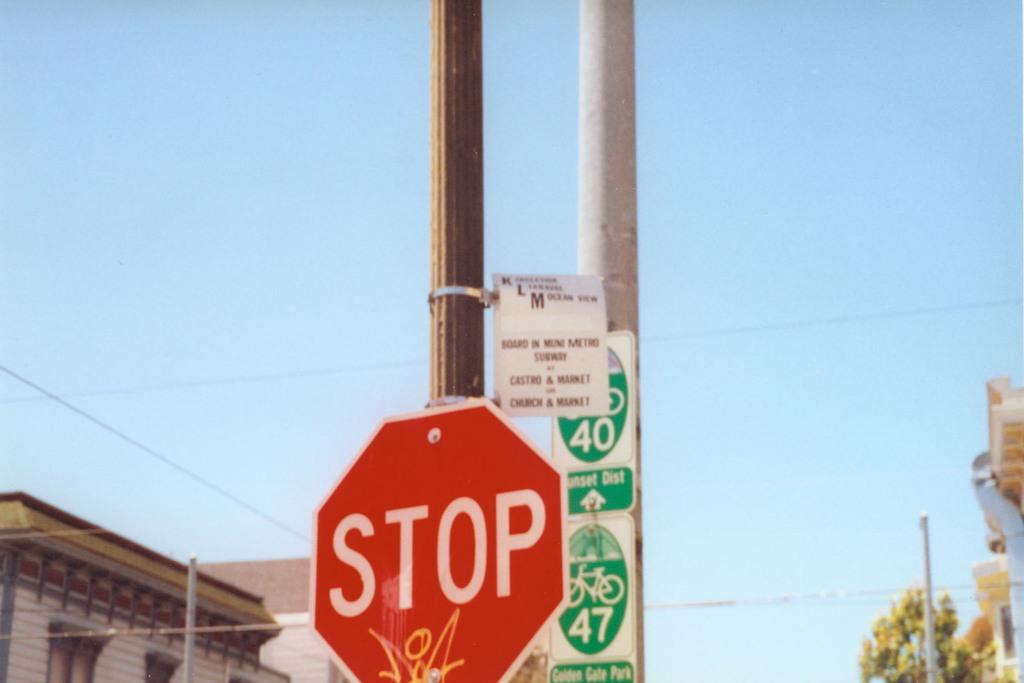<image>
Share a concise interpretation of the image provided. A red sign that says Stop has yellow graffiti on it. 